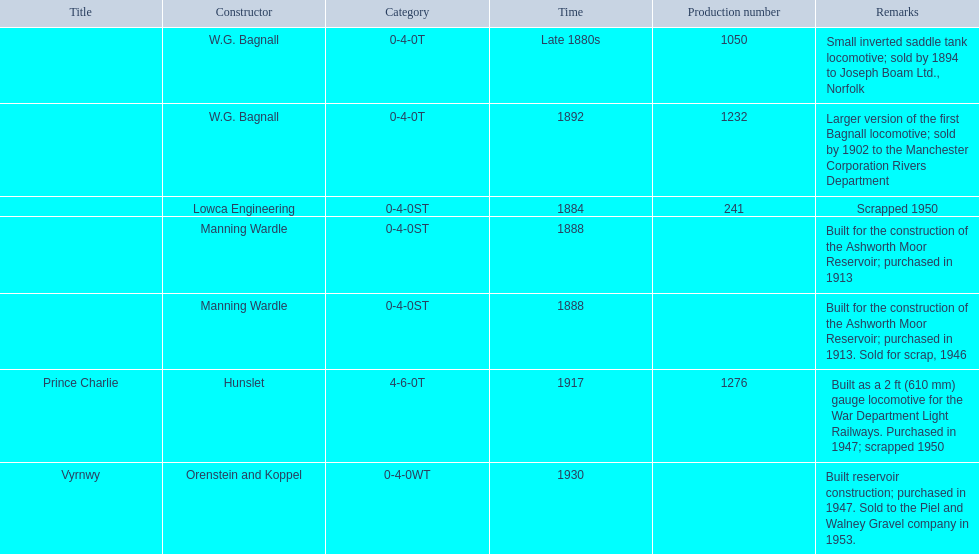Which locomotive builder built a locomotive after 1888 and built the locomotive as a 2ft gauge locomotive? Hunslet. Would you mind parsing the complete table? {'header': ['Title', 'Constructor', 'Category', 'Time', 'Production number', 'Remarks'], 'rows': [['', 'W.G. Bagnall', '0-4-0T', 'Late 1880s', '1050', 'Small inverted saddle tank locomotive; sold by 1894 to Joseph Boam Ltd., Norfolk'], ['', 'W.G. Bagnall', '0-4-0T', '1892', '1232', 'Larger version of the first Bagnall locomotive; sold by 1902 to the Manchester Corporation Rivers Department'], ['', 'Lowca Engineering', '0-4-0ST', '1884', '241', 'Scrapped 1950'], ['', 'Manning Wardle', '0-4-0ST', '1888', '', 'Built for the construction of the Ashworth Moor Reservoir; purchased in 1913'], ['', 'Manning Wardle', '0-4-0ST', '1888', '', 'Built for the construction of the Ashworth Moor Reservoir; purchased in 1913. Sold for scrap, 1946'], ['Prince Charlie', 'Hunslet', '4-6-0T', '1917', '1276', 'Built as a 2\xa0ft (610\xa0mm) gauge locomotive for the War Department Light Railways. Purchased in 1947; scrapped 1950'], ['Vyrnwy', 'Orenstein and Koppel', '0-4-0WT', '1930', '', 'Built reservoir construction; purchased in 1947. Sold to the Piel and Walney Gravel company in 1953.']]} 